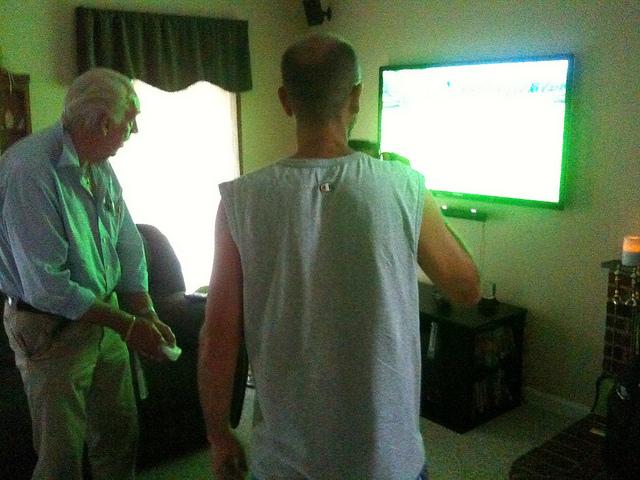What is on the wall in front of the men?
Concise answer only. Tv. Why are they standing?
Concise answer only. Yes. Are these men playing a Wii?
Quick response, please. Yes. 